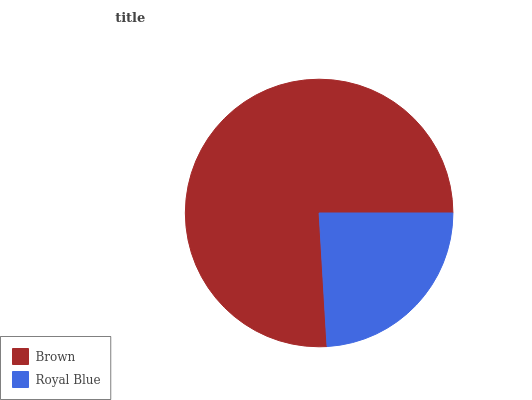Is Royal Blue the minimum?
Answer yes or no. Yes. Is Brown the maximum?
Answer yes or no. Yes. Is Royal Blue the maximum?
Answer yes or no. No. Is Brown greater than Royal Blue?
Answer yes or no. Yes. Is Royal Blue less than Brown?
Answer yes or no. Yes. Is Royal Blue greater than Brown?
Answer yes or no. No. Is Brown less than Royal Blue?
Answer yes or no. No. Is Brown the high median?
Answer yes or no. Yes. Is Royal Blue the low median?
Answer yes or no. Yes. Is Royal Blue the high median?
Answer yes or no. No. Is Brown the low median?
Answer yes or no. No. 